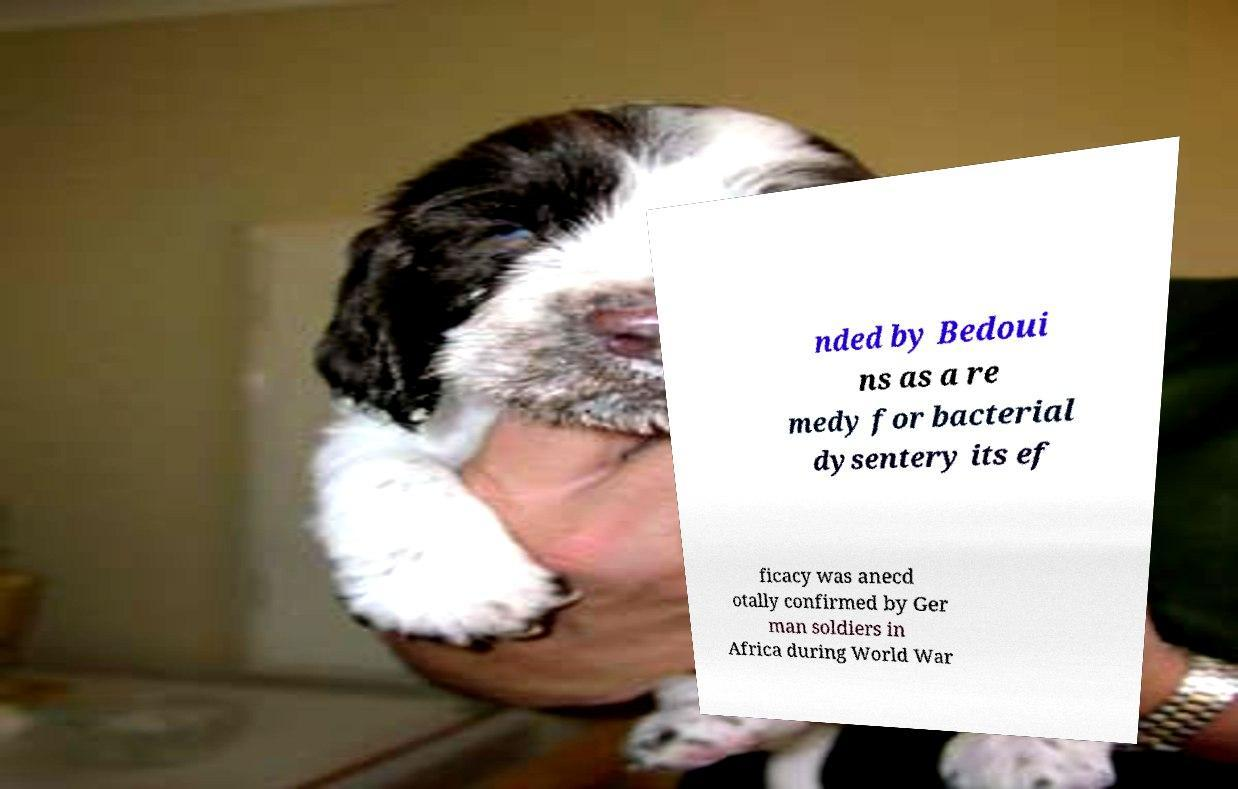Can you read and provide the text displayed in the image?This photo seems to have some interesting text. Can you extract and type it out for me? nded by Bedoui ns as a re medy for bacterial dysentery its ef ficacy was anecd otally confirmed by Ger man soldiers in Africa during World War 